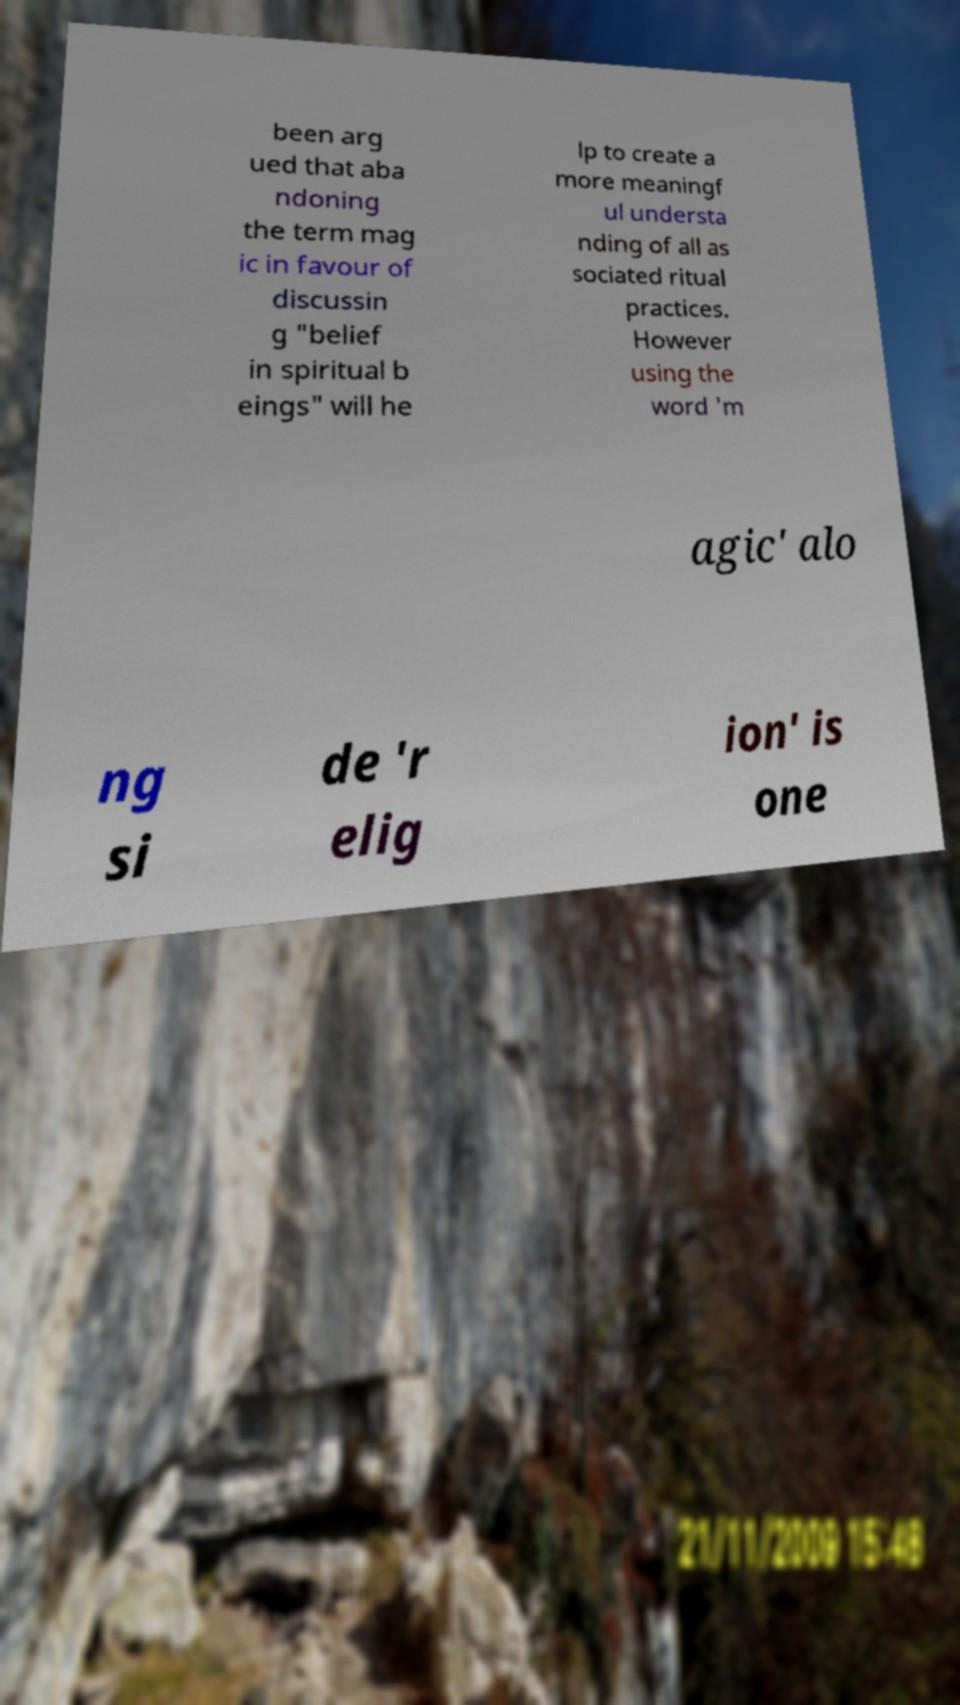Please identify and transcribe the text found in this image. been arg ued that aba ndoning the term mag ic in favour of discussin g "belief in spiritual b eings" will he lp to create a more meaningf ul understa nding of all as sociated ritual practices. However using the word 'm agic' alo ng si de 'r elig ion' is one 